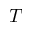Convert formula to latex. <formula><loc_0><loc_0><loc_500><loc_500>T</formula> 